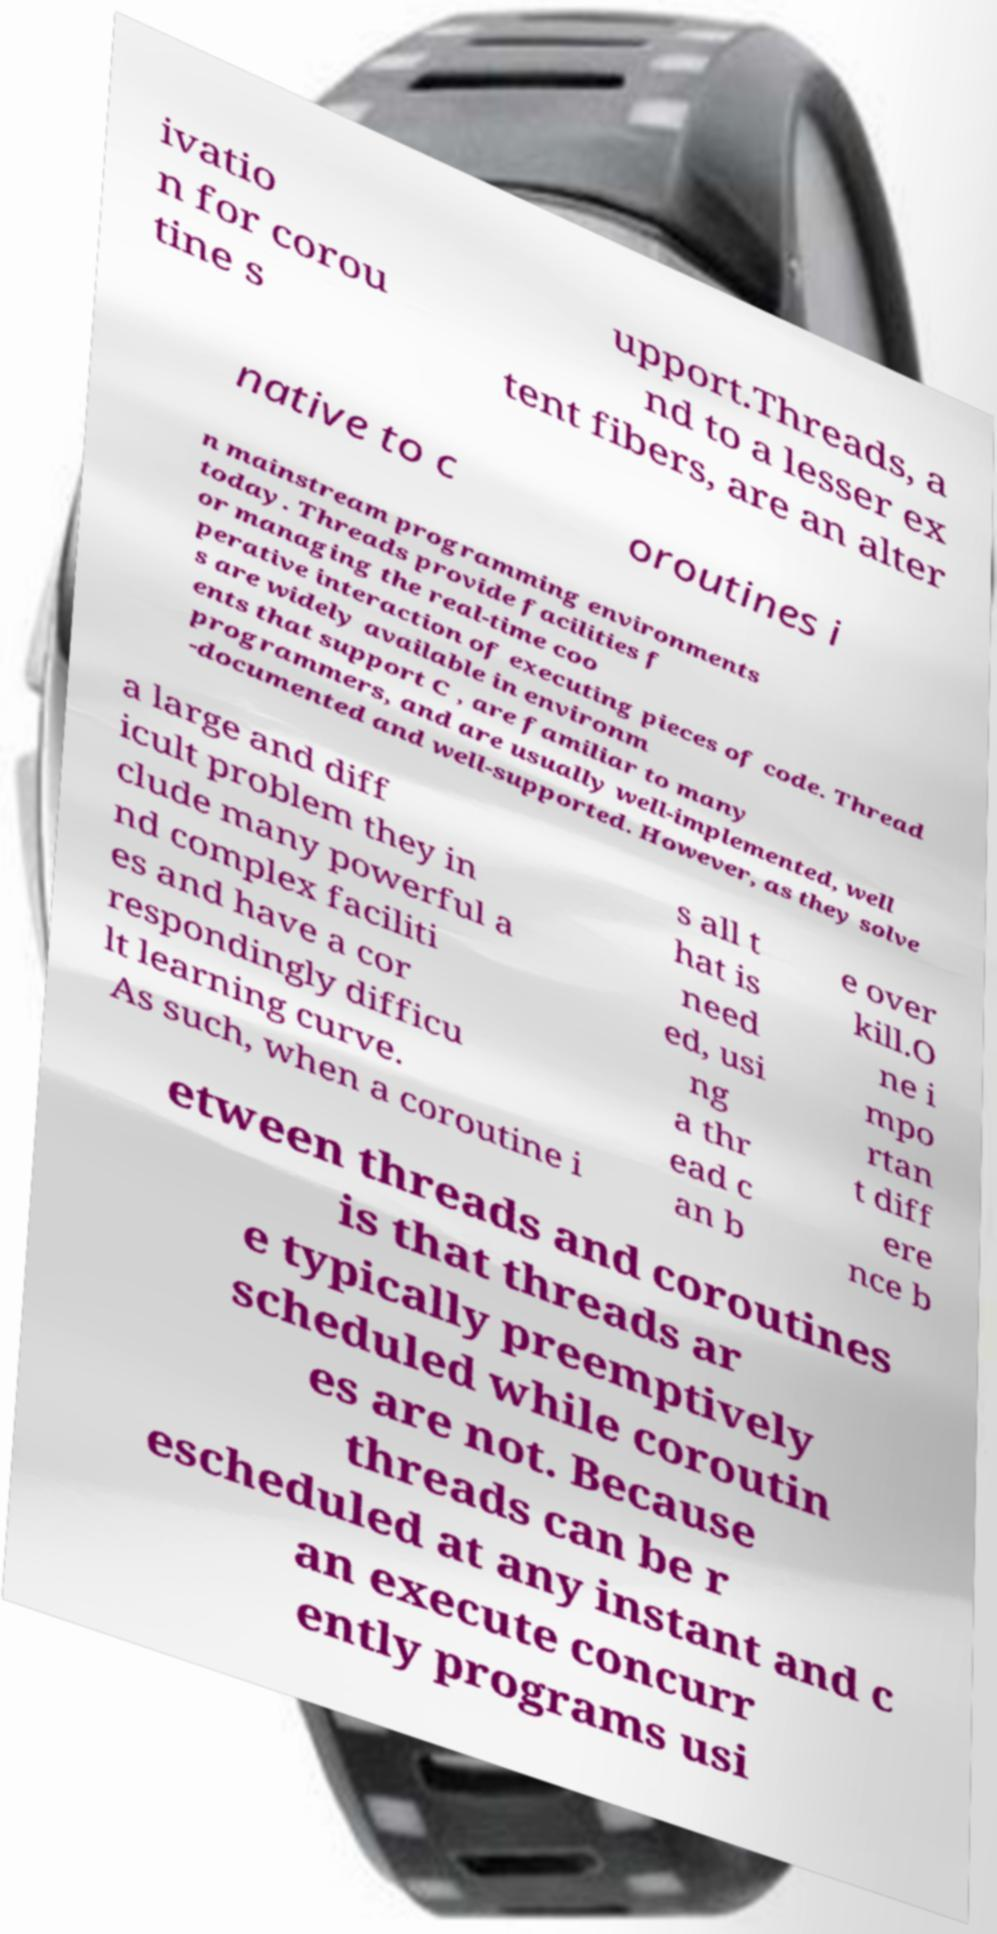Please identify and transcribe the text found in this image. ivatio n for corou tine s upport.Threads, a nd to a lesser ex tent fibers, are an alter native to c oroutines i n mainstream programming environments today. Threads provide facilities f or managing the real-time coo perative interaction of executing pieces of code. Thread s are widely available in environm ents that support C , are familiar to many programmers, and are usually well-implemented, well -documented and well-supported. However, as they solve a large and diff icult problem they in clude many powerful a nd complex faciliti es and have a cor respondingly difficu lt learning curve. As such, when a coroutine i s all t hat is need ed, usi ng a thr ead c an b e over kill.O ne i mpo rtan t diff ere nce b etween threads and coroutines is that threads ar e typically preemptively scheduled while coroutin es are not. Because threads can be r escheduled at any instant and c an execute concurr ently programs usi 